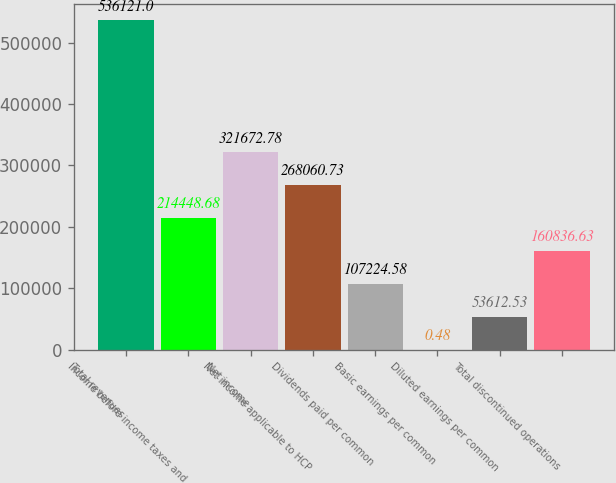Convert chart. <chart><loc_0><loc_0><loc_500><loc_500><bar_chart><fcel>Total revenues<fcel>Income before income taxes and<fcel>Net income<fcel>Net income applicable to HCP<fcel>Dividends paid per common<fcel>Basic earnings per common<fcel>Diluted earnings per common<fcel>Total discontinued operations<nl><fcel>536121<fcel>214449<fcel>321673<fcel>268061<fcel>107225<fcel>0.48<fcel>53612.5<fcel>160837<nl></chart> 